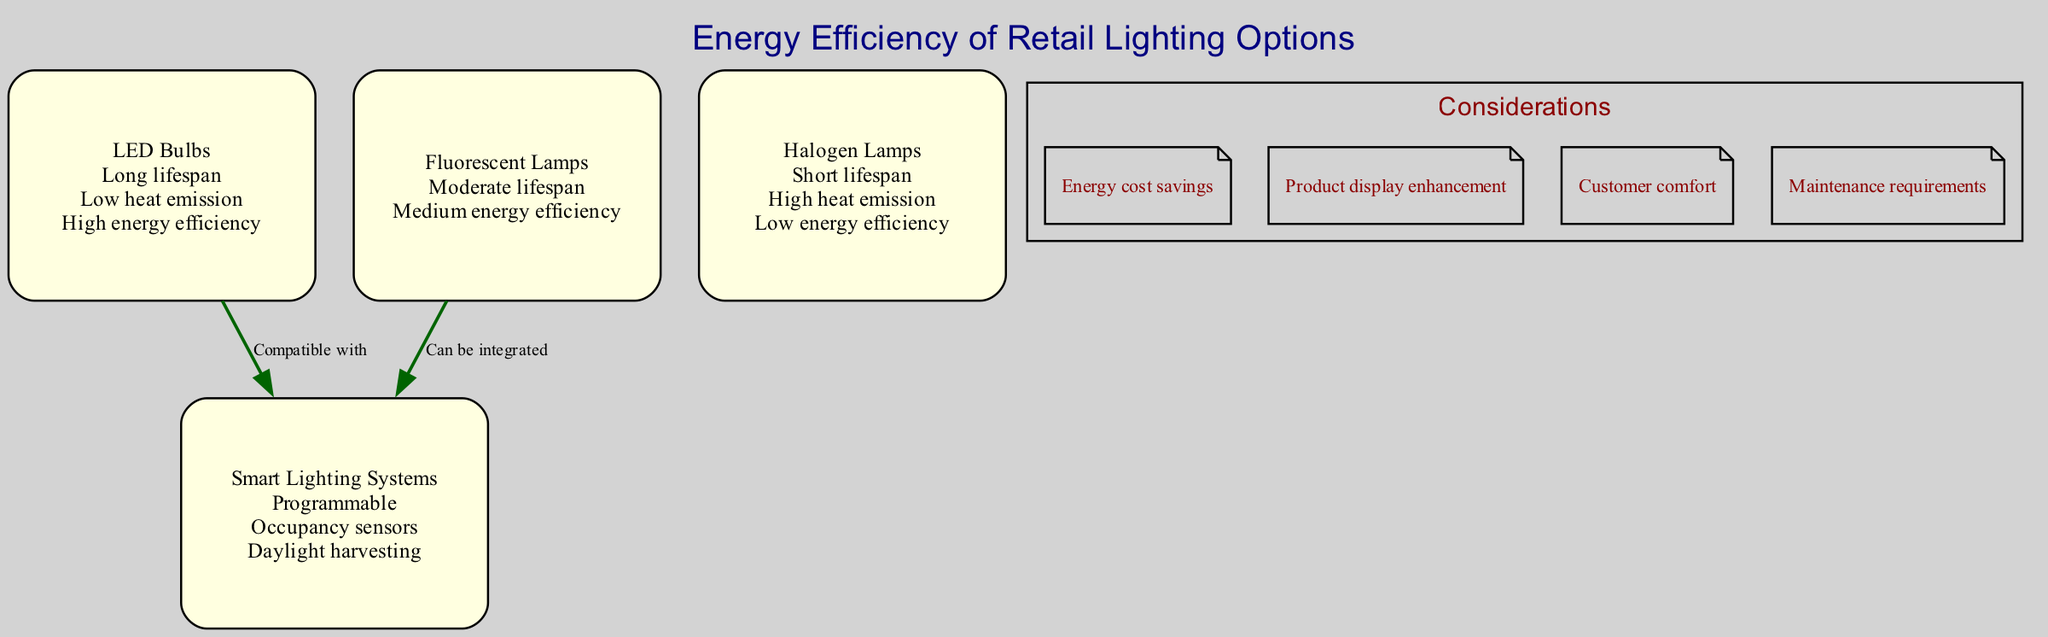What is the energy efficiency attribute of LED Bulbs? The LED Bulbs node lists three attributes, one of which is "High energy efficiency". This directly answers the question about the attribute related to energy efficiency for this specific lighting option.
Answer: High energy efficiency What relationship exists between LED Bulbs and Smart Lighting Systems? The diagram shows an edge connecting LED Bulbs to Smart Lighting Systems, labeled "Compatible with". This indicates that these two nodes have a compatible relationship.
Answer: Compatible with How many lighting options are represented in the diagram? The diagram contains four nodes, each representing different lighting options: LED Bulbs, Fluorescent Lamps, Halogen Lamps, and Smart Lighting Systems. Counting these, we find there are four options.
Answer: 4 Which lighting option has a short lifespan? The Halogen Lamps node specifically mentions "Short lifespan" as one of its attributes. This points directly to the answer.
Answer: Halogen Lamps Can Fluorescent Lamps be integrated with Smart Lighting Systems? The edge labeled "Can be integrated" connects Fluorescent Lamps to Smart Lighting Systems. This confirms that Fluorescent Lamps can indeed work with Smart Lighting Systems.
Answer: Can be integrated What is the main benefit of using LED Bulbs mentioned in the annotations? The annotation list includes "Energy cost savings", which is a primary benefit of using LED Bulbs in retail spaces, as noted in the context of energy efficiency.
Answer: Energy cost savings How many edges are present in the diagram? There are two edges connecting different nodes: one between LED Bulbs and Smart Lighting Systems, and another between Fluorescent Lamps and Smart Lighting Systems. Counting these gives a total of two edges.
Answer: 2 Which lighting option emits the most heat? The attributes of Halogen Lamps include "High heat emission", indicating that this lighting option results in the most heat compared to the others listed.
Answer: Halogen Lamps What functionality is unique to Smart Lighting Systems? The Smart Lighting Systems node indicates features like "Programmable", "Occupancy sensors", and "Daylight harvesting". These functionalities are distinct characteristics not found in the other lighting options.
Answer: Programmable 